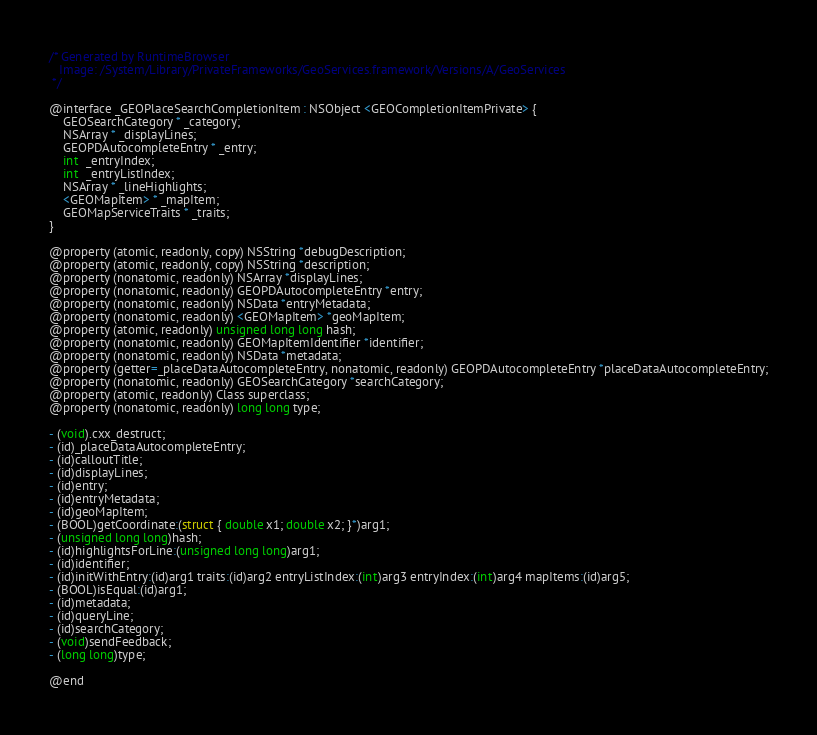<code> <loc_0><loc_0><loc_500><loc_500><_C_>/* Generated by RuntimeBrowser
   Image: /System/Library/PrivateFrameworks/GeoServices.framework/Versions/A/GeoServices
 */

@interface _GEOPlaceSearchCompletionItem : NSObject <GEOCompletionItemPrivate> {
    GEOSearchCategory * _category;
    NSArray * _displayLines;
    GEOPDAutocompleteEntry * _entry;
    int  _entryIndex;
    int  _entryListIndex;
    NSArray * _lineHighlights;
    <GEOMapItem> * _mapItem;
    GEOMapServiceTraits * _traits;
}

@property (atomic, readonly, copy) NSString *debugDescription;
@property (atomic, readonly, copy) NSString *description;
@property (nonatomic, readonly) NSArray *displayLines;
@property (nonatomic, readonly) GEOPDAutocompleteEntry *entry;
@property (nonatomic, readonly) NSData *entryMetadata;
@property (nonatomic, readonly) <GEOMapItem> *geoMapItem;
@property (atomic, readonly) unsigned long long hash;
@property (nonatomic, readonly) GEOMapItemIdentifier *identifier;
@property (nonatomic, readonly) NSData *metadata;
@property (getter=_placeDataAutocompleteEntry, nonatomic, readonly) GEOPDAutocompleteEntry *placeDataAutocompleteEntry;
@property (nonatomic, readonly) GEOSearchCategory *searchCategory;
@property (atomic, readonly) Class superclass;
@property (nonatomic, readonly) long long type;

- (void).cxx_destruct;
- (id)_placeDataAutocompleteEntry;
- (id)calloutTitle;
- (id)displayLines;
- (id)entry;
- (id)entryMetadata;
- (id)geoMapItem;
- (BOOL)getCoordinate:(struct { double x1; double x2; }*)arg1;
- (unsigned long long)hash;
- (id)highlightsForLine:(unsigned long long)arg1;
- (id)identifier;
- (id)initWithEntry:(id)arg1 traits:(id)arg2 entryListIndex:(int)arg3 entryIndex:(int)arg4 mapItems:(id)arg5;
- (BOOL)isEqual:(id)arg1;
- (id)metadata;
- (id)queryLine;
- (id)searchCategory;
- (void)sendFeedback;
- (long long)type;

@end
</code> 